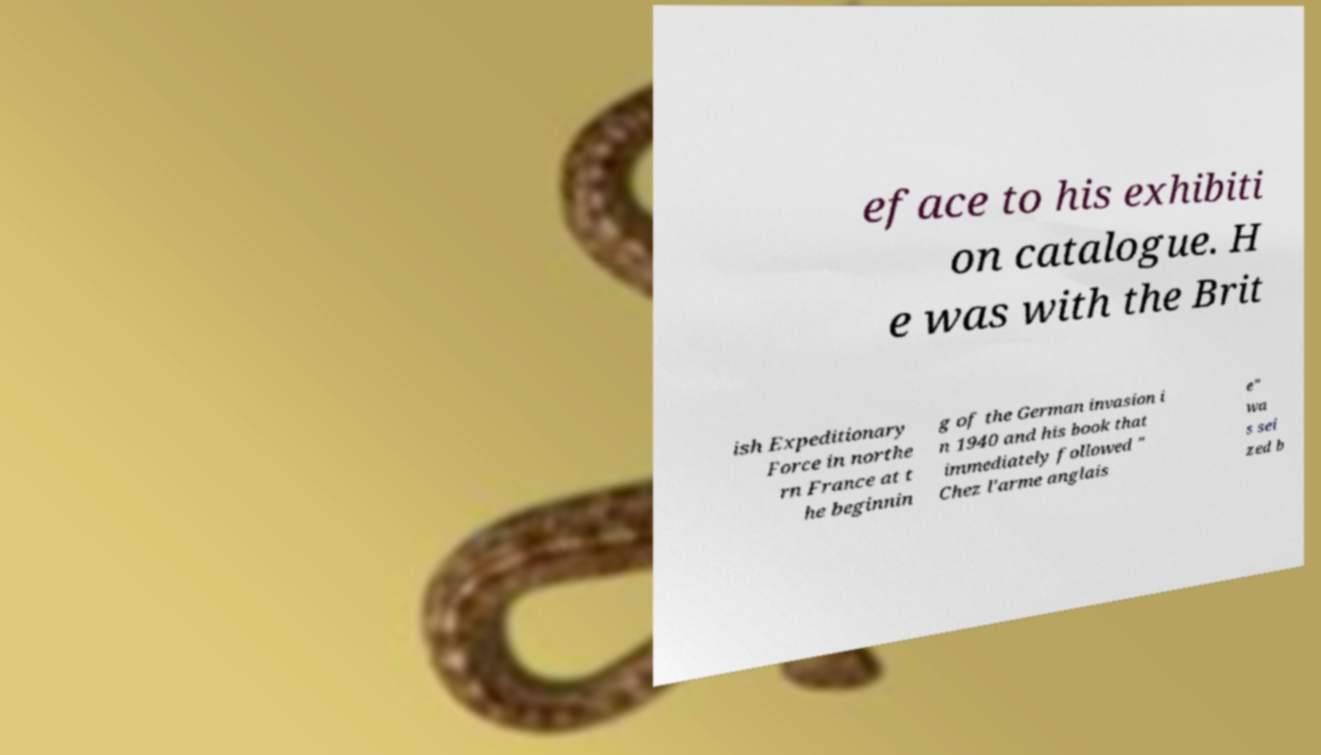What messages or text are displayed in this image? I need them in a readable, typed format. eface to his exhibiti on catalogue. H e was with the Brit ish Expeditionary Force in northe rn France at t he beginnin g of the German invasion i n 1940 and his book that immediately followed " Chez l'arme anglais e" wa s sei zed b 